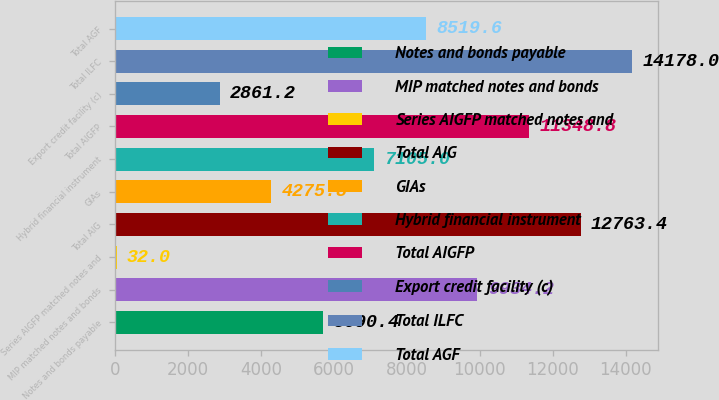Convert chart. <chart><loc_0><loc_0><loc_500><loc_500><bar_chart><fcel>Notes and bonds payable<fcel>MIP matched notes and bonds<fcel>Series AIGFP matched notes and<fcel>Total AIG<fcel>GIAs<fcel>Hybrid financial instrument<fcel>Total AIGFP<fcel>Export credit facility (c)<fcel>Total ILFC<fcel>Total AGF<nl><fcel>5690.4<fcel>9934.2<fcel>32<fcel>12763.4<fcel>4275.8<fcel>7105<fcel>11348.8<fcel>2861.2<fcel>14178<fcel>8519.6<nl></chart> 